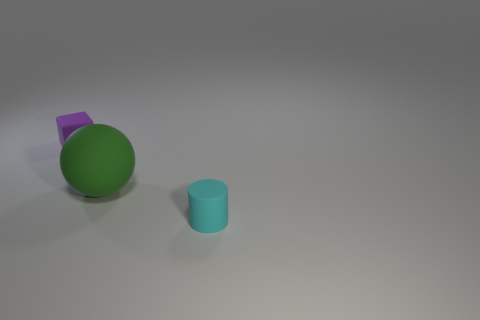Add 3 balls. How many objects exist? 6 Subtract all cubes. How many objects are left? 2 Subtract all rubber blocks. Subtract all balls. How many objects are left? 1 Add 3 green matte balls. How many green matte balls are left? 4 Add 2 big gray things. How many big gray things exist? 2 Subtract 0 purple cylinders. How many objects are left? 3 